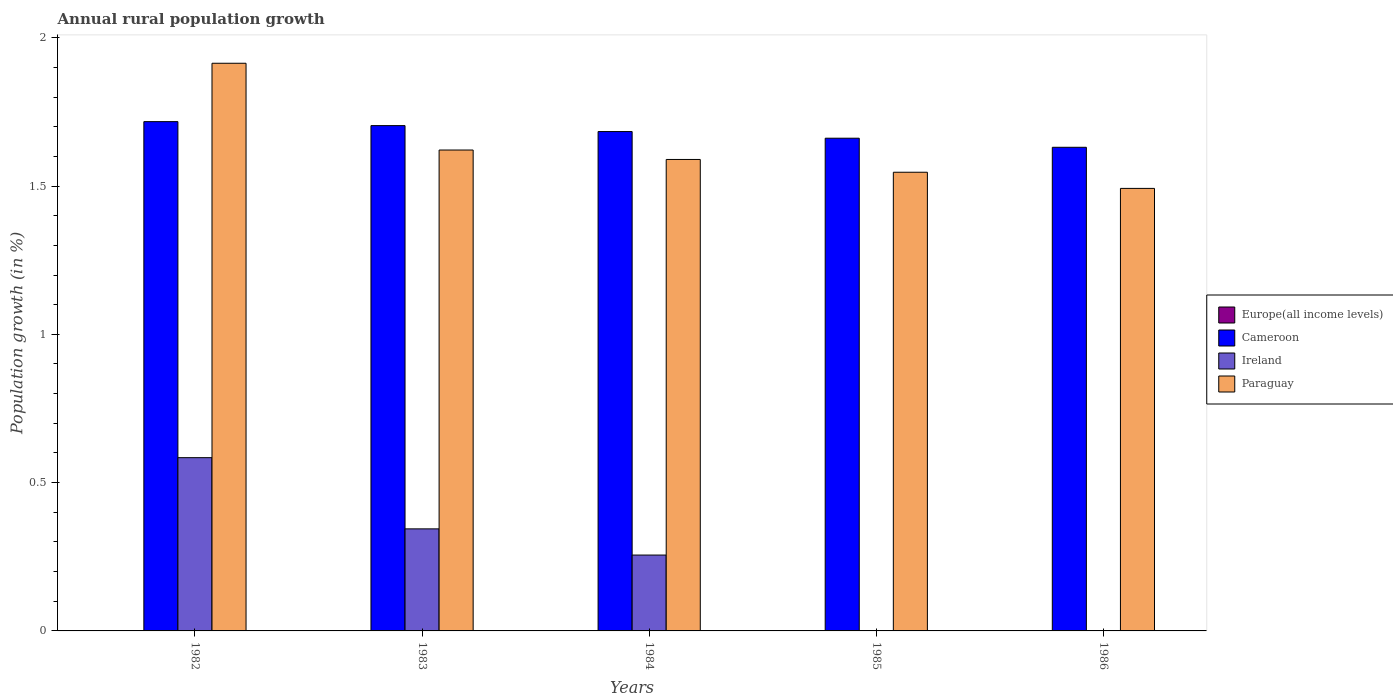How many groups of bars are there?
Ensure brevity in your answer.  5. Are the number of bars per tick equal to the number of legend labels?
Your response must be concise. No. Are the number of bars on each tick of the X-axis equal?
Offer a very short reply. No. What is the percentage of rural population growth in Cameroon in 1982?
Your answer should be compact. 1.72. Across all years, what is the maximum percentage of rural population growth in Paraguay?
Ensure brevity in your answer.  1.91. Across all years, what is the minimum percentage of rural population growth in Europe(all income levels)?
Your response must be concise. 0. In which year was the percentage of rural population growth in Ireland maximum?
Make the answer very short. 1982. What is the total percentage of rural population growth in Europe(all income levels) in the graph?
Ensure brevity in your answer.  0. What is the difference between the percentage of rural population growth in Paraguay in 1984 and that in 1985?
Your answer should be very brief. 0.04. What is the difference between the percentage of rural population growth in Europe(all income levels) in 1982 and the percentage of rural population growth in Ireland in 1983?
Make the answer very short. -0.34. In the year 1982, what is the difference between the percentage of rural population growth in Ireland and percentage of rural population growth in Cameroon?
Offer a very short reply. -1.13. In how many years, is the percentage of rural population growth in Cameroon greater than 0.4 %?
Keep it short and to the point. 5. What is the ratio of the percentage of rural population growth in Cameroon in 1984 to that in 1986?
Keep it short and to the point. 1.03. Is the percentage of rural population growth in Ireland in 1983 less than that in 1984?
Offer a terse response. No. Is the difference between the percentage of rural population growth in Ireland in 1983 and 1984 greater than the difference between the percentage of rural population growth in Cameroon in 1983 and 1984?
Ensure brevity in your answer.  Yes. What is the difference between the highest and the second highest percentage of rural population growth in Ireland?
Provide a succinct answer. 0.24. What is the difference between the highest and the lowest percentage of rural population growth in Cameroon?
Keep it short and to the point. 0.09. In how many years, is the percentage of rural population growth in Paraguay greater than the average percentage of rural population growth in Paraguay taken over all years?
Offer a very short reply. 1. Is the sum of the percentage of rural population growth in Paraguay in 1982 and 1985 greater than the maximum percentage of rural population growth in Ireland across all years?
Your answer should be compact. Yes. Is it the case that in every year, the sum of the percentage of rural population growth in Paraguay and percentage of rural population growth in Cameroon is greater than the sum of percentage of rural population growth in Europe(all income levels) and percentage of rural population growth in Ireland?
Your answer should be very brief. No. Is it the case that in every year, the sum of the percentage of rural population growth in Cameroon and percentage of rural population growth in Paraguay is greater than the percentage of rural population growth in Ireland?
Ensure brevity in your answer.  Yes. Are all the bars in the graph horizontal?
Your answer should be compact. No. Are the values on the major ticks of Y-axis written in scientific E-notation?
Ensure brevity in your answer.  No. Where does the legend appear in the graph?
Provide a short and direct response. Center right. How many legend labels are there?
Your response must be concise. 4. How are the legend labels stacked?
Offer a terse response. Vertical. What is the title of the graph?
Your answer should be very brief. Annual rural population growth. What is the label or title of the Y-axis?
Offer a terse response. Population growth (in %). What is the Population growth (in %) in Europe(all income levels) in 1982?
Make the answer very short. 0. What is the Population growth (in %) of Cameroon in 1982?
Your answer should be compact. 1.72. What is the Population growth (in %) in Ireland in 1982?
Make the answer very short. 0.58. What is the Population growth (in %) in Paraguay in 1982?
Offer a terse response. 1.91. What is the Population growth (in %) in Cameroon in 1983?
Offer a very short reply. 1.7. What is the Population growth (in %) of Ireland in 1983?
Offer a terse response. 0.34. What is the Population growth (in %) in Paraguay in 1983?
Offer a terse response. 1.62. What is the Population growth (in %) of Cameroon in 1984?
Your response must be concise. 1.68. What is the Population growth (in %) in Ireland in 1984?
Your answer should be compact. 0.26. What is the Population growth (in %) in Paraguay in 1984?
Offer a very short reply. 1.59. What is the Population growth (in %) in Cameroon in 1985?
Your answer should be very brief. 1.66. What is the Population growth (in %) in Ireland in 1985?
Provide a succinct answer. 0. What is the Population growth (in %) of Paraguay in 1985?
Offer a very short reply. 1.55. What is the Population growth (in %) of Europe(all income levels) in 1986?
Your response must be concise. 0. What is the Population growth (in %) in Cameroon in 1986?
Your answer should be compact. 1.63. What is the Population growth (in %) of Ireland in 1986?
Your response must be concise. 0. What is the Population growth (in %) in Paraguay in 1986?
Offer a terse response. 1.49. Across all years, what is the maximum Population growth (in %) in Cameroon?
Your answer should be compact. 1.72. Across all years, what is the maximum Population growth (in %) of Ireland?
Your answer should be very brief. 0.58. Across all years, what is the maximum Population growth (in %) of Paraguay?
Make the answer very short. 1.91. Across all years, what is the minimum Population growth (in %) in Cameroon?
Ensure brevity in your answer.  1.63. Across all years, what is the minimum Population growth (in %) in Ireland?
Ensure brevity in your answer.  0. Across all years, what is the minimum Population growth (in %) of Paraguay?
Give a very brief answer. 1.49. What is the total Population growth (in %) in Europe(all income levels) in the graph?
Provide a succinct answer. 0. What is the total Population growth (in %) in Cameroon in the graph?
Offer a terse response. 8.4. What is the total Population growth (in %) in Ireland in the graph?
Your response must be concise. 1.18. What is the total Population growth (in %) in Paraguay in the graph?
Make the answer very short. 8.16. What is the difference between the Population growth (in %) in Cameroon in 1982 and that in 1983?
Offer a very short reply. 0.01. What is the difference between the Population growth (in %) of Ireland in 1982 and that in 1983?
Provide a short and direct response. 0.24. What is the difference between the Population growth (in %) in Paraguay in 1982 and that in 1983?
Give a very brief answer. 0.29. What is the difference between the Population growth (in %) in Cameroon in 1982 and that in 1984?
Offer a terse response. 0.03. What is the difference between the Population growth (in %) of Ireland in 1982 and that in 1984?
Your response must be concise. 0.33. What is the difference between the Population growth (in %) of Paraguay in 1982 and that in 1984?
Your answer should be very brief. 0.32. What is the difference between the Population growth (in %) of Cameroon in 1982 and that in 1985?
Provide a short and direct response. 0.06. What is the difference between the Population growth (in %) of Paraguay in 1982 and that in 1985?
Give a very brief answer. 0.37. What is the difference between the Population growth (in %) in Cameroon in 1982 and that in 1986?
Make the answer very short. 0.09. What is the difference between the Population growth (in %) in Paraguay in 1982 and that in 1986?
Make the answer very short. 0.42. What is the difference between the Population growth (in %) of Cameroon in 1983 and that in 1984?
Keep it short and to the point. 0.02. What is the difference between the Population growth (in %) of Ireland in 1983 and that in 1984?
Provide a succinct answer. 0.09. What is the difference between the Population growth (in %) of Paraguay in 1983 and that in 1984?
Offer a very short reply. 0.03. What is the difference between the Population growth (in %) in Cameroon in 1983 and that in 1985?
Offer a very short reply. 0.04. What is the difference between the Population growth (in %) of Paraguay in 1983 and that in 1985?
Offer a terse response. 0.07. What is the difference between the Population growth (in %) in Cameroon in 1983 and that in 1986?
Your answer should be compact. 0.07. What is the difference between the Population growth (in %) in Paraguay in 1983 and that in 1986?
Provide a short and direct response. 0.13. What is the difference between the Population growth (in %) of Cameroon in 1984 and that in 1985?
Provide a short and direct response. 0.02. What is the difference between the Population growth (in %) of Paraguay in 1984 and that in 1985?
Provide a short and direct response. 0.04. What is the difference between the Population growth (in %) of Cameroon in 1984 and that in 1986?
Your response must be concise. 0.05. What is the difference between the Population growth (in %) of Paraguay in 1984 and that in 1986?
Provide a succinct answer. 0.1. What is the difference between the Population growth (in %) in Cameroon in 1985 and that in 1986?
Provide a succinct answer. 0.03. What is the difference between the Population growth (in %) of Paraguay in 1985 and that in 1986?
Your answer should be very brief. 0.05. What is the difference between the Population growth (in %) in Cameroon in 1982 and the Population growth (in %) in Ireland in 1983?
Offer a very short reply. 1.37. What is the difference between the Population growth (in %) of Cameroon in 1982 and the Population growth (in %) of Paraguay in 1983?
Provide a short and direct response. 0.1. What is the difference between the Population growth (in %) in Ireland in 1982 and the Population growth (in %) in Paraguay in 1983?
Provide a succinct answer. -1.04. What is the difference between the Population growth (in %) in Cameroon in 1982 and the Population growth (in %) in Ireland in 1984?
Make the answer very short. 1.46. What is the difference between the Population growth (in %) in Cameroon in 1982 and the Population growth (in %) in Paraguay in 1984?
Ensure brevity in your answer.  0.13. What is the difference between the Population growth (in %) of Ireland in 1982 and the Population growth (in %) of Paraguay in 1984?
Give a very brief answer. -1.01. What is the difference between the Population growth (in %) of Cameroon in 1982 and the Population growth (in %) of Paraguay in 1985?
Make the answer very short. 0.17. What is the difference between the Population growth (in %) of Ireland in 1982 and the Population growth (in %) of Paraguay in 1985?
Make the answer very short. -0.96. What is the difference between the Population growth (in %) in Cameroon in 1982 and the Population growth (in %) in Paraguay in 1986?
Make the answer very short. 0.23. What is the difference between the Population growth (in %) in Ireland in 1982 and the Population growth (in %) in Paraguay in 1986?
Make the answer very short. -0.91. What is the difference between the Population growth (in %) in Cameroon in 1983 and the Population growth (in %) in Ireland in 1984?
Ensure brevity in your answer.  1.45. What is the difference between the Population growth (in %) of Cameroon in 1983 and the Population growth (in %) of Paraguay in 1984?
Your response must be concise. 0.11. What is the difference between the Population growth (in %) of Ireland in 1983 and the Population growth (in %) of Paraguay in 1984?
Provide a succinct answer. -1.25. What is the difference between the Population growth (in %) in Cameroon in 1983 and the Population growth (in %) in Paraguay in 1985?
Keep it short and to the point. 0.16. What is the difference between the Population growth (in %) of Ireland in 1983 and the Population growth (in %) of Paraguay in 1985?
Give a very brief answer. -1.2. What is the difference between the Population growth (in %) of Cameroon in 1983 and the Population growth (in %) of Paraguay in 1986?
Provide a succinct answer. 0.21. What is the difference between the Population growth (in %) in Ireland in 1983 and the Population growth (in %) in Paraguay in 1986?
Offer a terse response. -1.15. What is the difference between the Population growth (in %) of Cameroon in 1984 and the Population growth (in %) of Paraguay in 1985?
Your answer should be very brief. 0.14. What is the difference between the Population growth (in %) of Ireland in 1984 and the Population growth (in %) of Paraguay in 1985?
Provide a succinct answer. -1.29. What is the difference between the Population growth (in %) of Cameroon in 1984 and the Population growth (in %) of Paraguay in 1986?
Make the answer very short. 0.19. What is the difference between the Population growth (in %) of Ireland in 1984 and the Population growth (in %) of Paraguay in 1986?
Give a very brief answer. -1.24. What is the difference between the Population growth (in %) of Cameroon in 1985 and the Population growth (in %) of Paraguay in 1986?
Give a very brief answer. 0.17. What is the average Population growth (in %) in Europe(all income levels) per year?
Give a very brief answer. 0. What is the average Population growth (in %) in Cameroon per year?
Your answer should be very brief. 1.68. What is the average Population growth (in %) of Ireland per year?
Give a very brief answer. 0.24. What is the average Population growth (in %) of Paraguay per year?
Offer a terse response. 1.63. In the year 1982, what is the difference between the Population growth (in %) in Cameroon and Population growth (in %) in Ireland?
Make the answer very short. 1.13. In the year 1982, what is the difference between the Population growth (in %) of Cameroon and Population growth (in %) of Paraguay?
Provide a short and direct response. -0.2. In the year 1982, what is the difference between the Population growth (in %) of Ireland and Population growth (in %) of Paraguay?
Give a very brief answer. -1.33. In the year 1983, what is the difference between the Population growth (in %) of Cameroon and Population growth (in %) of Ireland?
Provide a short and direct response. 1.36. In the year 1983, what is the difference between the Population growth (in %) of Cameroon and Population growth (in %) of Paraguay?
Your response must be concise. 0.08. In the year 1983, what is the difference between the Population growth (in %) in Ireland and Population growth (in %) in Paraguay?
Offer a very short reply. -1.28. In the year 1984, what is the difference between the Population growth (in %) of Cameroon and Population growth (in %) of Ireland?
Offer a very short reply. 1.43. In the year 1984, what is the difference between the Population growth (in %) of Cameroon and Population growth (in %) of Paraguay?
Make the answer very short. 0.09. In the year 1984, what is the difference between the Population growth (in %) of Ireland and Population growth (in %) of Paraguay?
Offer a terse response. -1.33. In the year 1985, what is the difference between the Population growth (in %) in Cameroon and Population growth (in %) in Paraguay?
Keep it short and to the point. 0.11. In the year 1986, what is the difference between the Population growth (in %) in Cameroon and Population growth (in %) in Paraguay?
Make the answer very short. 0.14. What is the ratio of the Population growth (in %) of Cameroon in 1982 to that in 1983?
Provide a succinct answer. 1.01. What is the ratio of the Population growth (in %) of Ireland in 1982 to that in 1983?
Provide a short and direct response. 1.7. What is the ratio of the Population growth (in %) of Paraguay in 1982 to that in 1983?
Your response must be concise. 1.18. What is the ratio of the Population growth (in %) in Cameroon in 1982 to that in 1984?
Make the answer very short. 1.02. What is the ratio of the Population growth (in %) in Ireland in 1982 to that in 1984?
Your answer should be compact. 2.28. What is the ratio of the Population growth (in %) of Paraguay in 1982 to that in 1984?
Offer a terse response. 1.2. What is the ratio of the Population growth (in %) of Cameroon in 1982 to that in 1985?
Make the answer very short. 1.03. What is the ratio of the Population growth (in %) of Paraguay in 1982 to that in 1985?
Your answer should be compact. 1.24. What is the ratio of the Population growth (in %) of Cameroon in 1982 to that in 1986?
Offer a very short reply. 1.05. What is the ratio of the Population growth (in %) of Paraguay in 1982 to that in 1986?
Provide a short and direct response. 1.28. What is the ratio of the Population growth (in %) of Cameroon in 1983 to that in 1984?
Your answer should be compact. 1.01. What is the ratio of the Population growth (in %) in Ireland in 1983 to that in 1984?
Ensure brevity in your answer.  1.35. What is the ratio of the Population growth (in %) in Cameroon in 1983 to that in 1985?
Provide a short and direct response. 1.03. What is the ratio of the Population growth (in %) of Paraguay in 1983 to that in 1985?
Your response must be concise. 1.05. What is the ratio of the Population growth (in %) of Cameroon in 1983 to that in 1986?
Make the answer very short. 1.04. What is the ratio of the Population growth (in %) of Paraguay in 1983 to that in 1986?
Offer a very short reply. 1.09. What is the ratio of the Population growth (in %) of Cameroon in 1984 to that in 1985?
Ensure brevity in your answer.  1.01. What is the ratio of the Population growth (in %) in Paraguay in 1984 to that in 1985?
Your response must be concise. 1.03. What is the ratio of the Population growth (in %) of Cameroon in 1984 to that in 1986?
Provide a short and direct response. 1.03. What is the ratio of the Population growth (in %) of Paraguay in 1984 to that in 1986?
Keep it short and to the point. 1.07. What is the ratio of the Population growth (in %) of Cameroon in 1985 to that in 1986?
Offer a very short reply. 1.02. What is the ratio of the Population growth (in %) in Paraguay in 1985 to that in 1986?
Provide a short and direct response. 1.04. What is the difference between the highest and the second highest Population growth (in %) in Cameroon?
Keep it short and to the point. 0.01. What is the difference between the highest and the second highest Population growth (in %) of Ireland?
Provide a short and direct response. 0.24. What is the difference between the highest and the second highest Population growth (in %) in Paraguay?
Give a very brief answer. 0.29. What is the difference between the highest and the lowest Population growth (in %) of Cameroon?
Ensure brevity in your answer.  0.09. What is the difference between the highest and the lowest Population growth (in %) in Ireland?
Your answer should be compact. 0.58. What is the difference between the highest and the lowest Population growth (in %) of Paraguay?
Offer a terse response. 0.42. 